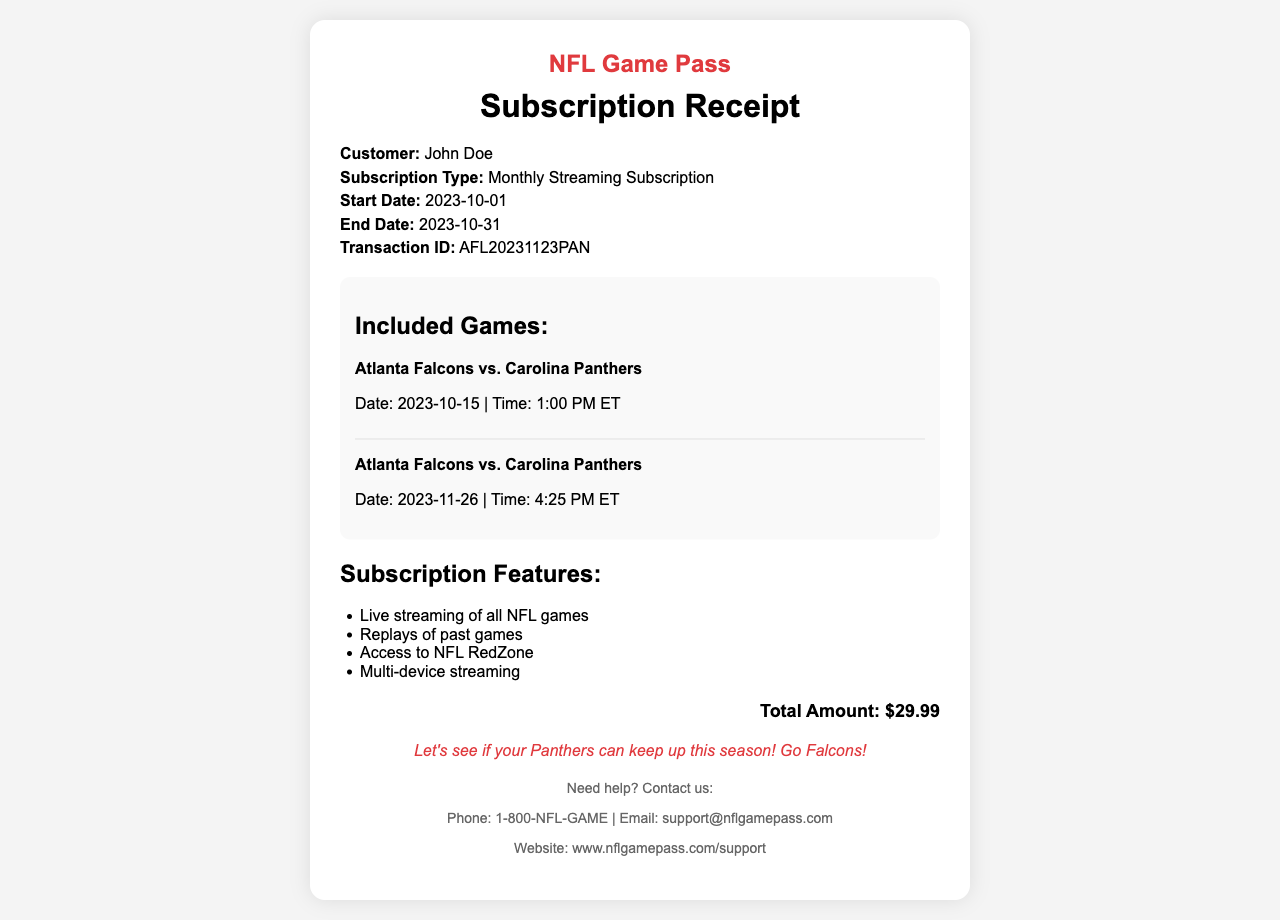What is the name of the customer? The customer’s name is displayed in the details section of the receipt.
Answer: John Doe What is the subscription type? The type of subscription is stated in the details section of the receipt.
Answer: Monthly Streaming Subscription What is the start date of the subscription? The start date can be found in the details section of the receipt.
Answer: 2023-10-01 How much is the total amount? The total amount is mentioned at the bottom of the receipt.
Answer: $29.99 How many games are included between the Falcons and Panthers? The number of games listed can be counted in the included games section on the receipt.
Answer: 2 What is the date of the first Falcons vs. Panthers game? The date of the first game is specified in the details of the included games section of the receipt.
Answer: 2023-10-15 What is one feature of the subscription? A list of subscription features is provided in the features section of the receipt.
Answer: Live streaming of all NFL games What is the transaction ID? The transaction ID is clearly outlined in the details section of the receipt.
Answer: AFL20231123PAN What is the contact phone number for support? The support contact information is provided at the bottom of the receipt.
Answer: 1-800-NFL-GAME 